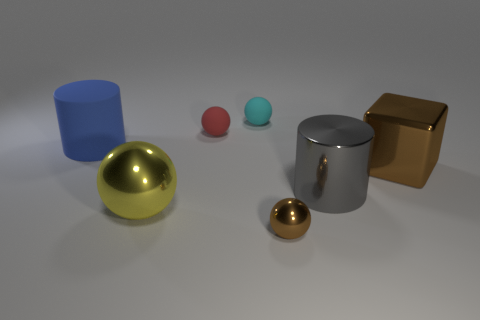Add 2 blue rubber objects. How many objects exist? 9 Subtract all tiny red spheres. How many spheres are left? 3 Subtract all cylinders. How many objects are left? 5 Add 6 small brown shiny objects. How many small brown shiny objects exist? 7 Subtract all brown spheres. How many spheres are left? 3 Subtract 1 brown cubes. How many objects are left? 6 Subtract 1 spheres. How many spheres are left? 3 Subtract all yellow balls. Subtract all red blocks. How many balls are left? 3 Subtract all gray cylinders. How many red balls are left? 1 Subtract all tiny red spheres. Subtract all gray metal cylinders. How many objects are left? 5 